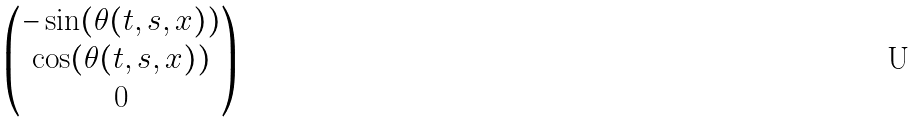Convert formula to latex. <formula><loc_0><loc_0><loc_500><loc_500>\begin{pmatrix} - \sin ( \theta ( t , s , x ) ) \\ \cos ( \theta ( t , s , x ) ) \\ 0 \end{pmatrix}</formula> 